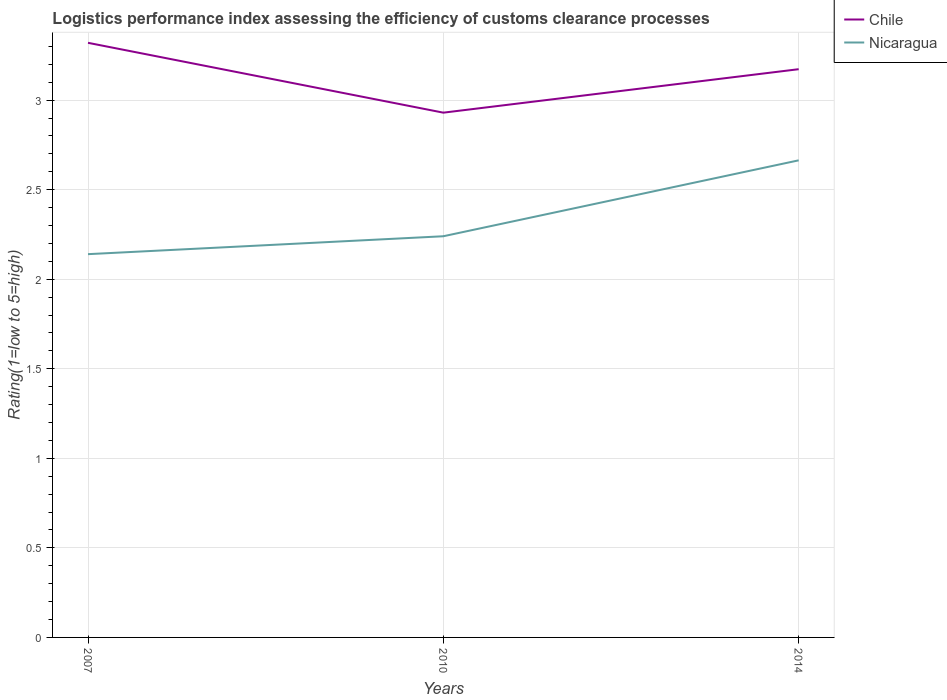How many different coloured lines are there?
Offer a terse response. 2. Does the line corresponding to Nicaragua intersect with the line corresponding to Chile?
Offer a very short reply. No. Is the number of lines equal to the number of legend labels?
Provide a short and direct response. Yes. Across all years, what is the maximum Logistic performance index in Chile?
Your answer should be very brief. 2.93. What is the total Logistic performance index in Nicaragua in the graph?
Ensure brevity in your answer.  -0.1. What is the difference between the highest and the second highest Logistic performance index in Nicaragua?
Offer a very short reply. 0.52. How many lines are there?
Your answer should be very brief. 2. Are the values on the major ticks of Y-axis written in scientific E-notation?
Ensure brevity in your answer.  No. Does the graph contain grids?
Offer a terse response. Yes. What is the title of the graph?
Your answer should be compact. Logistics performance index assessing the efficiency of customs clearance processes. Does "Mauritania" appear as one of the legend labels in the graph?
Keep it short and to the point. No. What is the label or title of the X-axis?
Make the answer very short. Years. What is the label or title of the Y-axis?
Your answer should be compact. Rating(1=low to 5=high). What is the Rating(1=low to 5=high) in Chile in 2007?
Keep it short and to the point. 3.32. What is the Rating(1=low to 5=high) in Nicaragua in 2007?
Your answer should be compact. 2.14. What is the Rating(1=low to 5=high) in Chile in 2010?
Keep it short and to the point. 2.93. What is the Rating(1=low to 5=high) in Nicaragua in 2010?
Your response must be concise. 2.24. What is the Rating(1=low to 5=high) of Chile in 2014?
Your response must be concise. 3.17. What is the Rating(1=low to 5=high) of Nicaragua in 2014?
Keep it short and to the point. 2.66. Across all years, what is the maximum Rating(1=low to 5=high) of Chile?
Provide a short and direct response. 3.32. Across all years, what is the maximum Rating(1=low to 5=high) in Nicaragua?
Ensure brevity in your answer.  2.66. Across all years, what is the minimum Rating(1=low to 5=high) in Chile?
Provide a short and direct response. 2.93. Across all years, what is the minimum Rating(1=low to 5=high) in Nicaragua?
Your answer should be very brief. 2.14. What is the total Rating(1=low to 5=high) of Chile in the graph?
Your answer should be compact. 9.42. What is the total Rating(1=low to 5=high) in Nicaragua in the graph?
Provide a succinct answer. 7.04. What is the difference between the Rating(1=low to 5=high) of Chile in 2007 and that in 2010?
Provide a succinct answer. 0.39. What is the difference between the Rating(1=low to 5=high) in Nicaragua in 2007 and that in 2010?
Your response must be concise. -0.1. What is the difference between the Rating(1=low to 5=high) in Chile in 2007 and that in 2014?
Provide a succinct answer. 0.15. What is the difference between the Rating(1=low to 5=high) of Nicaragua in 2007 and that in 2014?
Keep it short and to the point. -0.52. What is the difference between the Rating(1=low to 5=high) of Chile in 2010 and that in 2014?
Provide a short and direct response. -0.24. What is the difference between the Rating(1=low to 5=high) in Nicaragua in 2010 and that in 2014?
Give a very brief answer. -0.42. What is the difference between the Rating(1=low to 5=high) in Chile in 2007 and the Rating(1=low to 5=high) in Nicaragua in 2014?
Offer a very short reply. 0.66. What is the difference between the Rating(1=low to 5=high) in Chile in 2010 and the Rating(1=low to 5=high) in Nicaragua in 2014?
Provide a short and direct response. 0.27. What is the average Rating(1=low to 5=high) of Chile per year?
Offer a very short reply. 3.14. What is the average Rating(1=low to 5=high) of Nicaragua per year?
Your answer should be compact. 2.35. In the year 2007, what is the difference between the Rating(1=low to 5=high) of Chile and Rating(1=low to 5=high) of Nicaragua?
Offer a very short reply. 1.18. In the year 2010, what is the difference between the Rating(1=low to 5=high) in Chile and Rating(1=low to 5=high) in Nicaragua?
Your response must be concise. 0.69. In the year 2014, what is the difference between the Rating(1=low to 5=high) of Chile and Rating(1=low to 5=high) of Nicaragua?
Your answer should be very brief. 0.51. What is the ratio of the Rating(1=low to 5=high) of Chile in 2007 to that in 2010?
Make the answer very short. 1.13. What is the ratio of the Rating(1=low to 5=high) of Nicaragua in 2007 to that in 2010?
Keep it short and to the point. 0.96. What is the ratio of the Rating(1=low to 5=high) of Chile in 2007 to that in 2014?
Keep it short and to the point. 1.05. What is the ratio of the Rating(1=low to 5=high) of Nicaragua in 2007 to that in 2014?
Your response must be concise. 0.8. What is the ratio of the Rating(1=low to 5=high) in Chile in 2010 to that in 2014?
Ensure brevity in your answer.  0.92. What is the ratio of the Rating(1=low to 5=high) in Nicaragua in 2010 to that in 2014?
Provide a succinct answer. 0.84. What is the difference between the highest and the second highest Rating(1=low to 5=high) of Chile?
Ensure brevity in your answer.  0.15. What is the difference between the highest and the second highest Rating(1=low to 5=high) in Nicaragua?
Ensure brevity in your answer.  0.42. What is the difference between the highest and the lowest Rating(1=low to 5=high) in Chile?
Your answer should be very brief. 0.39. What is the difference between the highest and the lowest Rating(1=low to 5=high) of Nicaragua?
Your answer should be very brief. 0.52. 